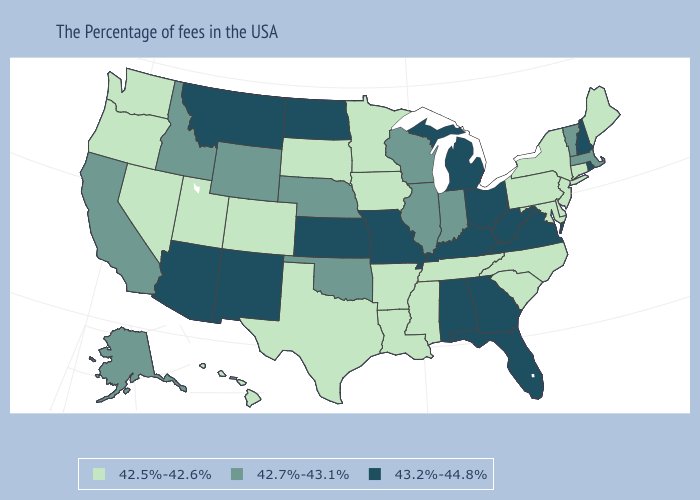What is the value of Minnesota?
Write a very short answer. 42.5%-42.6%. Which states hav the highest value in the South?
Concise answer only. Virginia, West Virginia, Florida, Georgia, Kentucky, Alabama. What is the lowest value in the West?
Quick response, please. 42.5%-42.6%. What is the lowest value in states that border Minnesota?
Answer briefly. 42.5%-42.6%. Name the states that have a value in the range 43.2%-44.8%?
Keep it brief. Rhode Island, New Hampshire, Virginia, West Virginia, Ohio, Florida, Georgia, Michigan, Kentucky, Alabama, Missouri, Kansas, North Dakota, New Mexico, Montana, Arizona. Does New Mexico have the highest value in the West?
Short answer required. Yes. Name the states that have a value in the range 42.5%-42.6%?
Answer briefly. Maine, Connecticut, New York, New Jersey, Delaware, Maryland, Pennsylvania, North Carolina, South Carolina, Tennessee, Mississippi, Louisiana, Arkansas, Minnesota, Iowa, Texas, South Dakota, Colorado, Utah, Nevada, Washington, Oregon, Hawaii. Which states have the lowest value in the South?
Keep it brief. Delaware, Maryland, North Carolina, South Carolina, Tennessee, Mississippi, Louisiana, Arkansas, Texas. Name the states that have a value in the range 42.5%-42.6%?
Concise answer only. Maine, Connecticut, New York, New Jersey, Delaware, Maryland, Pennsylvania, North Carolina, South Carolina, Tennessee, Mississippi, Louisiana, Arkansas, Minnesota, Iowa, Texas, South Dakota, Colorado, Utah, Nevada, Washington, Oregon, Hawaii. What is the value of Hawaii?
Concise answer only. 42.5%-42.6%. Does Indiana have the lowest value in the USA?
Short answer required. No. Does the map have missing data?
Give a very brief answer. No. What is the value of Ohio?
Keep it brief. 43.2%-44.8%. Name the states that have a value in the range 42.5%-42.6%?
Answer briefly. Maine, Connecticut, New York, New Jersey, Delaware, Maryland, Pennsylvania, North Carolina, South Carolina, Tennessee, Mississippi, Louisiana, Arkansas, Minnesota, Iowa, Texas, South Dakota, Colorado, Utah, Nevada, Washington, Oregon, Hawaii. 